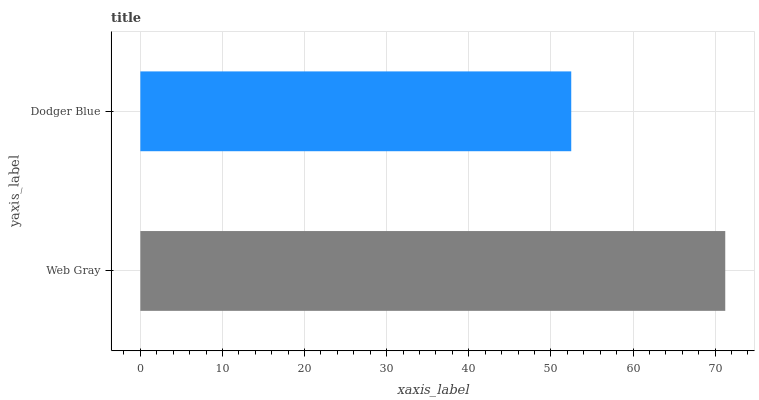Is Dodger Blue the minimum?
Answer yes or no. Yes. Is Web Gray the maximum?
Answer yes or no. Yes. Is Dodger Blue the maximum?
Answer yes or no. No. Is Web Gray greater than Dodger Blue?
Answer yes or no. Yes. Is Dodger Blue less than Web Gray?
Answer yes or no. Yes. Is Dodger Blue greater than Web Gray?
Answer yes or no. No. Is Web Gray less than Dodger Blue?
Answer yes or no. No. Is Web Gray the high median?
Answer yes or no. Yes. Is Dodger Blue the low median?
Answer yes or no. Yes. Is Dodger Blue the high median?
Answer yes or no. No. Is Web Gray the low median?
Answer yes or no. No. 